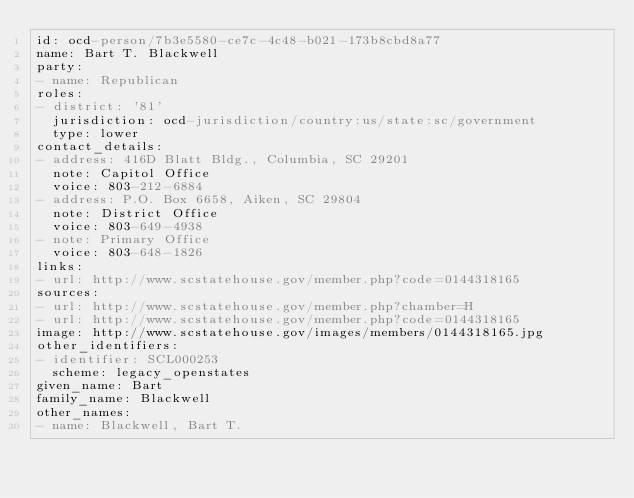<code> <loc_0><loc_0><loc_500><loc_500><_YAML_>id: ocd-person/7b3e5580-ce7c-4c48-b021-173b8cbd8a77
name: Bart T. Blackwell
party:
- name: Republican
roles:
- district: '81'
  jurisdiction: ocd-jurisdiction/country:us/state:sc/government
  type: lower
contact_details:
- address: 416D Blatt Bldg., Columbia, SC 29201
  note: Capitol Office
  voice: 803-212-6884
- address: P.O. Box 6658, Aiken, SC 29804
  note: District Office
  voice: 803-649-4938
- note: Primary Office
  voice: 803-648-1826
links:
- url: http://www.scstatehouse.gov/member.php?code=0144318165
sources:
- url: http://www.scstatehouse.gov/member.php?chamber=H
- url: http://www.scstatehouse.gov/member.php?code=0144318165
image: http://www.scstatehouse.gov/images/members/0144318165.jpg
other_identifiers:
- identifier: SCL000253
  scheme: legacy_openstates
given_name: Bart
family_name: Blackwell
other_names:
- name: Blackwell, Bart T.
</code> 